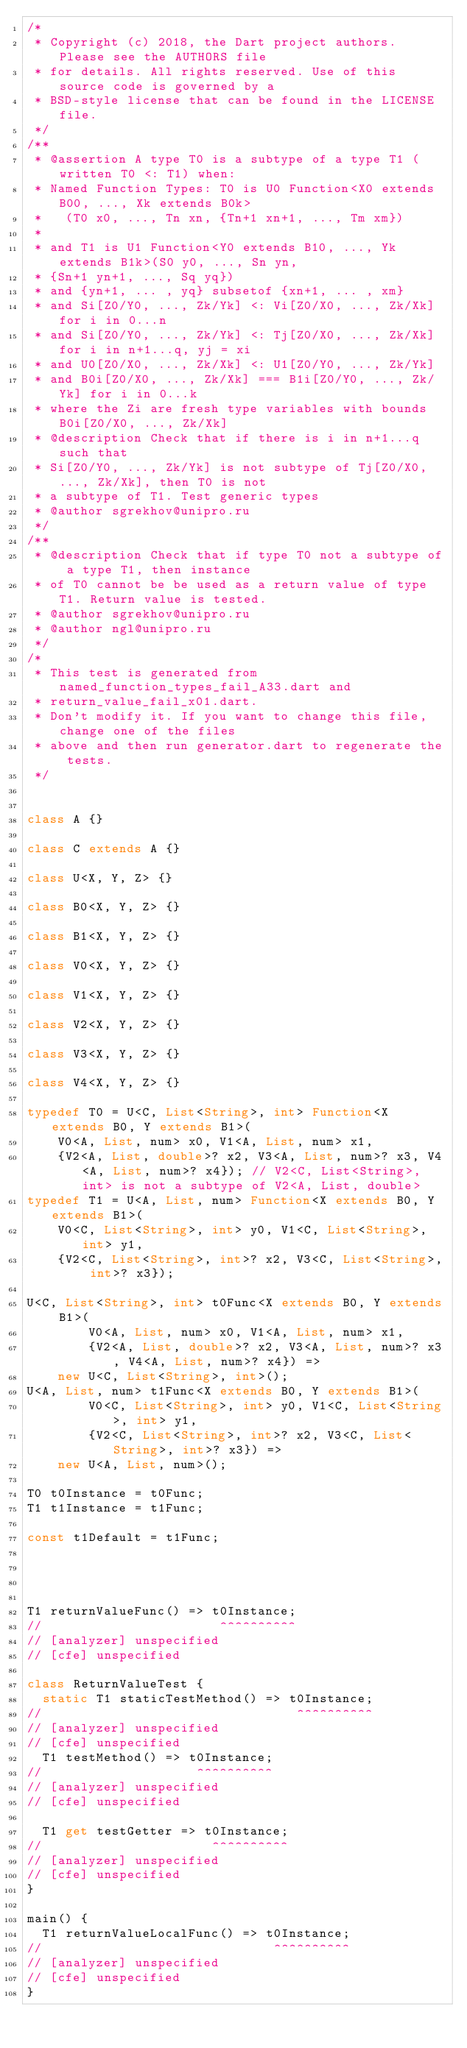<code> <loc_0><loc_0><loc_500><loc_500><_Dart_>/*
 * Copyright (c) 2018, the Dart project authors.  Please see the AUTHORS file
 * for details. All rights reserved. Use of this source code is governed by a
 * BSD-style license that can be found in the LICENSE file.
 */
/**
 * @assertion A type T0 is a subtype of a type T1 (written T0 <: T1) when:
 * Named Function Types: T0 is U0 Function<X0 extends B00, ..., Xk extends B0k>
 *   (T0 x0, ..., Tn xn, {Tn+1 xn+1, ..., Tm xm})
 *
 * and T1 is U1 Function<Y0 extends B10, ..., Yk extends B1k>(S0 y0, ..., Sn yn,
 * {Sn+1 yn+1, ..., Sq yq})
 * and {yn+1, ... , yq} subsetof {xn+1, ... , xm}
 * and Si[Z0/Y0, ..., Zk/Yk] <: Vi[Z0/X0, ..., Zk/Xk] for i in 0...n
 * and Si[Z0/Y0, ..., Zk/Yk] <: Tj[Z0/X0, ..., Zk/Xk] for i in n+1...q, yj = xi
 * and U0[Z0/X0, ..., Zk/Xk] <: U1[Z0/Y0, ..., Zk/Yk]
 * and B0i[Z0/X0, ..., Zk/Xk] === B1i[Z0/Y0, ..., Zk/Yk] for i in 0...k
 * where the Zi are fresh type variables with bounds B0i[Z0/X0, ..., Zk/Xk]
 * @description Check that if there is i in n+1...q such that
 * Si[Z0/Y0, ..., Zk/Yk] is not subtype of Tj[Z0/X0, ..., Zk/Xk], then T0 is not
 * a subtype of T1. Test generic types
 * @author sgrekhov@unipro.ru
 */
/**
 * @description Check that if type T0 not a subtype of a type T1, then instance
 * of T0 cannot be be used as a return value of type T1. Return value is tested.
 * @author sgrekhov@unipro.ru
 * @author ngl@unipro.ru
 */
/*
 * This test is generated from named_function_types_fail_A33.dart and 
 * return_value_fail_x01.dart.
 * Don't modify it. If you want to change this file, change one of the files 
 * above and then run generator.dart to regenerate the tests.
 */


class A {}

class C extends A {}

class U<X, Y, Z> {}

class B0<X, Y, Z> {}

class B1<X, Y, Z> {}

class V0<X, Y, Z> {}

class V1<X, Y, Z> {}

class V2<X, Y, Z> {}

class V3<X, Y, Z> {}

class V4<X, Y, Z> {}

typedef T0 = U<C, List<String>, int> Function<X extends B0, Y extends B1>(
    V0<A, List, num> x0, V1<A, List, num> x1,
    {V2<A, List, double>? x2, V3<A, List, num>? x3, V4<A, List, num>? x4}); // V2<C, List<String>, int> is not a subtype of V2<A, List, double>
typedef T1 = U<A, List, num> Function<X extends B0, Y extends B1>(
    V0<C, List<String>, int> y0, V1<C, List<String>, int> y1,
    {V2<C, List<String>, int>? x2, V3<C, List<String>, int>? x3});

U<C, List<String>, int> t0Func<X extends B0, Y extends B1>(
        V0<A, List, num> x0, V1<A, List, num> x1,
        {V2<A, List, double>? x2, V3<A, List, num>? x3, V4<A, List, num>? x4}) =>
    new U<C, List<String>, int>();
U<A, List, num> t1Func<X extends B0, Y extends B1>(
        V0<C, List<String>, int> y0, V1<C, List<String>, int> y1,
        {V2<C, List<String>, int>? x2, V3<C, List<String>, int>? x3}) =>
    new U<A, List, num>();

T0 t0Instance = t0Func;
T1 t1Instance = t1Func;

const t1Default = t1Func;




T1 returnValueFunc() => t0Instance;
//                       ^^^^^^^^^^
// [analyzer] unspecified
// [cfe] unspecified

class ReturnValueTest {
  static T1 staticTestMethod() => t0Instance;
//                                 ^^^^^^^^^^
// [analyzer] unspecified
// [cfe] unspecified
  T1 testMethod() => t0Instance;
//                    ^^^^^^^^^^
// [analyzer] unspecified
// [cfe] unspecified

  T1 get testGetter => t0Instance;
//                      ^^^^^^^^^^
// [analyzer] unspecified
// [cfe] unspecified
}

main() {
  T1 returnValueLocalFunc() => t0Instance;
//                              ^^^^^^^^^^
// [analyzer] unspecified
// [cfe] unspecified
}

</code> 